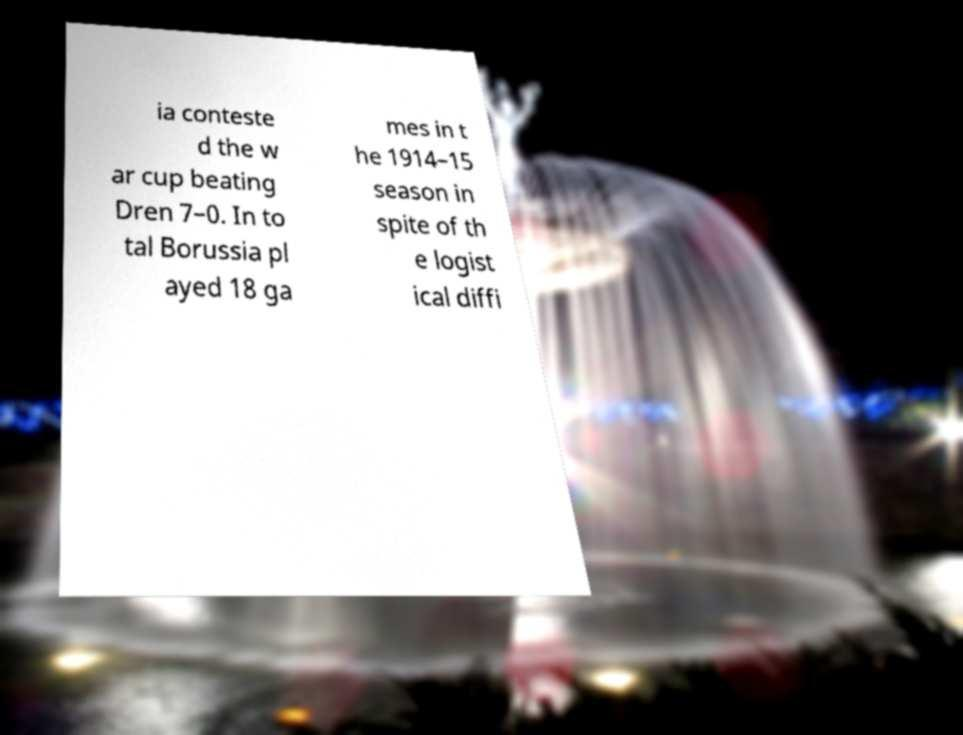Please identify and transcribe the text found in this image. ia conteste d the w ar cup beating Dren 7–0. In to tal Borussia pl ayed 18 ga mes in t he 1914–15 season in spite of th e logist ical diffi 